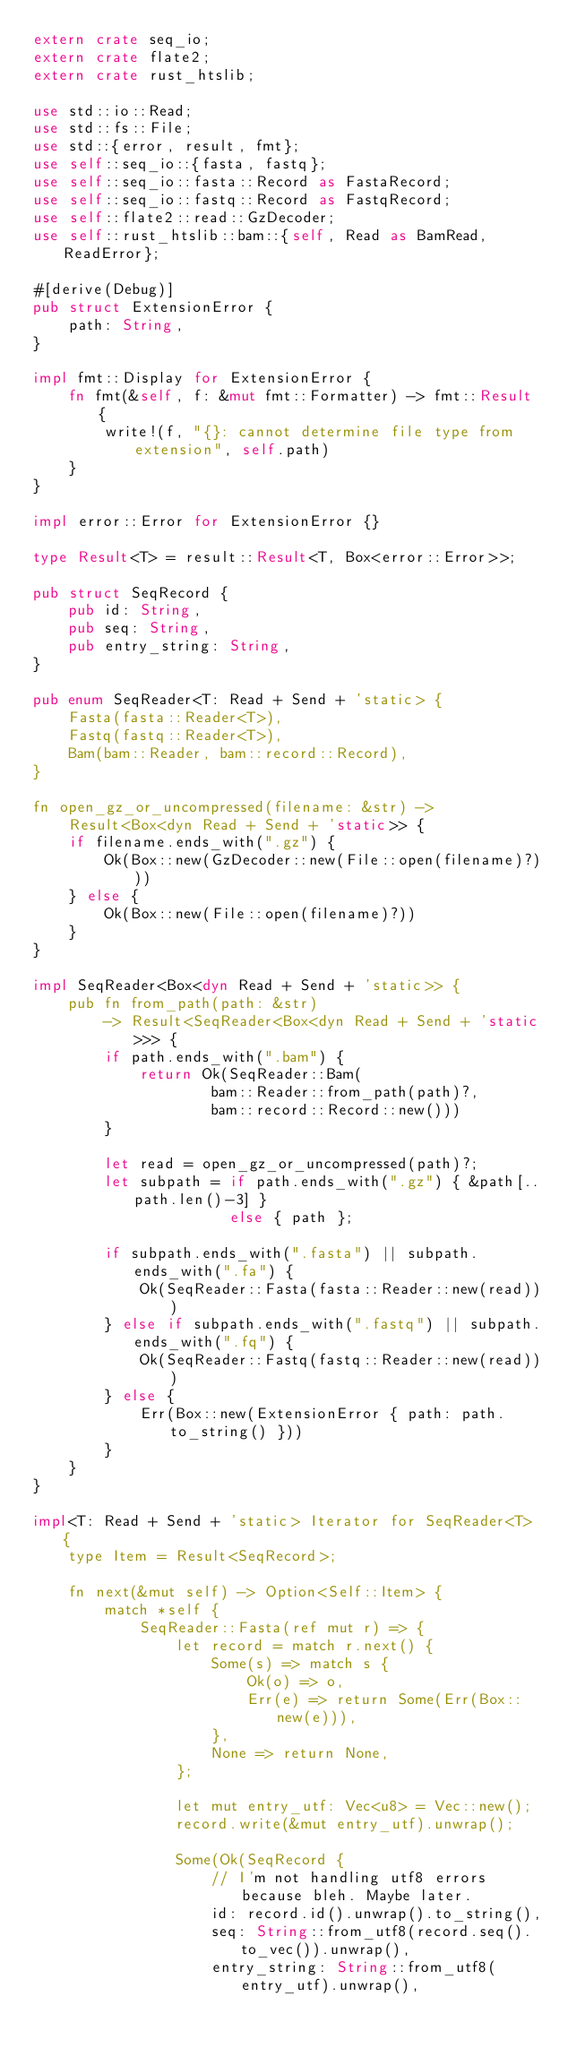Convert code to text. <code><loc_0><loc_0><loc_500><loc_500><_Rust_>extern crate seq_io;
extern crate flate2;
extern crate rust_htslib;

use std::io::Read;
use std::fs::File;
use std::{error, result, fmt};
use self::seq_io::{fasta, fastq};
use self::seq_io::fasta::Record as FastaRecord;
use self::seq_io::fastq::Record as FastqRecord;
use self::flate2::read::GzDecoder;
use self::rust_htslib::bam::{self, Read as BamRead, ReadError};

#[derive(Debug)]
pub struct ExtensionError {
    path: String,
}

impl fmt::Display for ExtensionError {
    fn fmt(&self, f: &mut fmt::Formatter) -> fmt::Result {
        write!(f, "{}: cannot determine file type from extension", self.path)
    }
}

impl error::Error for ExtensionError {}

type Result<T> = result::Result<T, Box<error::Error>>;

pub struct SeqRecord {
    pub id: String,
    pub seq: String,
    pub entry_string: String,
}

pub enum SeqReader<T: Read + Send + 'static> {
    Fasta(fasta::Reader<T>),
    Fastq(fastq::Reader<T>),
    Bam(bam::Reader, bam::record::Record),
}

fn open_gz_or_uncompressed(filename: &str) ->
    Result<Box<dyn Read + Send + 'static>> {
    if filename.ends_with(".gz") {
        Ok(Box::new(GzDecoder::new(File::open(filename)?)))
    } else {
        Ok(Box::new(File::open(filename)?))
    }
}

impl SeqReader<Box<dyn Read + Send + 'static>> {
    pub fn from_path(path: &str)
        -> Result<SeqReader<Box<dyn Read + Send + 'static>>> {
        if path.ends_with(".bam") {
            return Ok(SeqReader::Bam(
                    bam::Reader::from_path(path)?,
                    bam::record::Record::new()))
        }

        let read = open_gz_or_uncompressed(path)?;
        let subpath = if path.ends_with(".gz") { &path[..path.len()-3] }
                      else { path };

        if subpath.ends_with(".fasta") || subpath.ends_with(".fa") {
            Ok(SeqReader::Fasta(fasta::Reader::new(read)))
        } else if subpath.ends_with(".fastq") || subpath.ends_with(".fq") {
            Ok(SeqReader::Fastq(fastq::Reader::new(read)))
        } else {
            Err(Box::new(ExtensionError { path: path.to_string() }))
        }
    }
}

impl<T: Read + Send + 'static> Iterator for SeqReader<T> {
    type Item = Result<SeqRecord>;

    fn next(&mut self) -> Option<Self::Item> {
        match *self {
            SeqReader::Fasta(ref mut r) => {
                let record = match r.next() {
                    Some(s) => match s {
                        Ok(o) => o,
                        Err(e) => return Some(Err(Box::new(e))),
                    },
                    None => return None,
                };

                let mut entry_utf: Vec<u8> = Vec::new();
                record.write(&mut entry_utf).unwrap();

                Some(Ok(SeqRecord {
                    // I'm not handling utf8 errors because bleh. Maybe later.
                    id: record.id().unwrap().to_string(),
                    seq: String::from_utf8(record.seq().to_vec()).unwrap(),
                    entry_string: String::from_utf8(entry_utf).unwrap(),</code> 